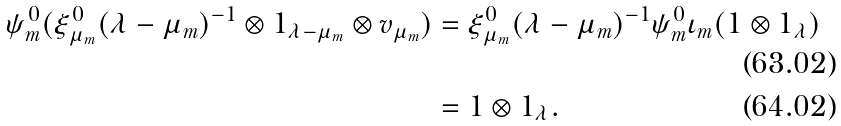Convert formula to latex. <formula><loc_0><loc_0><loc_500><loc_500>\psi _ { m } ^ { 0 } ( \xi _ { \mu _ { m } } ^ { 0 } ( \lambda - \mu _ { m } ) ^ { - 1 } \otimes 1 _ { \lambda - \mu _ { m } } \otimes v _ { \mu _ { m } } ) & = \xi _ { \mu _ { m } } ^ { 0 } ( \lambda - \mu _ { m } ) ^ { - 1 } \psi _ { m } ^ { 0 } \iota _ { m } ( 1 \otimes 1 _ { \lambda } ) \\ & = 1 \otimes 1 _ { \lambda } .</formula> 